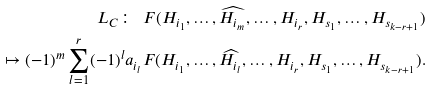<formula> <loc_0><loc_0><loc_500><loc_500>L _ { C } \colon \ F ( H _ { i _ { 1 } } , \dots , \widehat { H _ { i _ { m } } } , \dots , H _ { i _ { r } } , H _ { s _ { 1 } } , \dots , H _ { s _ { k - r + 1 } } ) \\ \quad \mapsto ( - 1 ) ^ { m } \sum _ { l = 1 } ^ { r } ( - 1 ) ^ { l } a _ { i _ { l } } F ( H _ { i _ { 1 } } , \dots , \widehat { H _ { i _ { l } } } , \dots , H _ { i _ { r } } , H _ { s _ { 1 } } , \dots , H _ { s _ { k - r + 1 } } ) .</formula> 